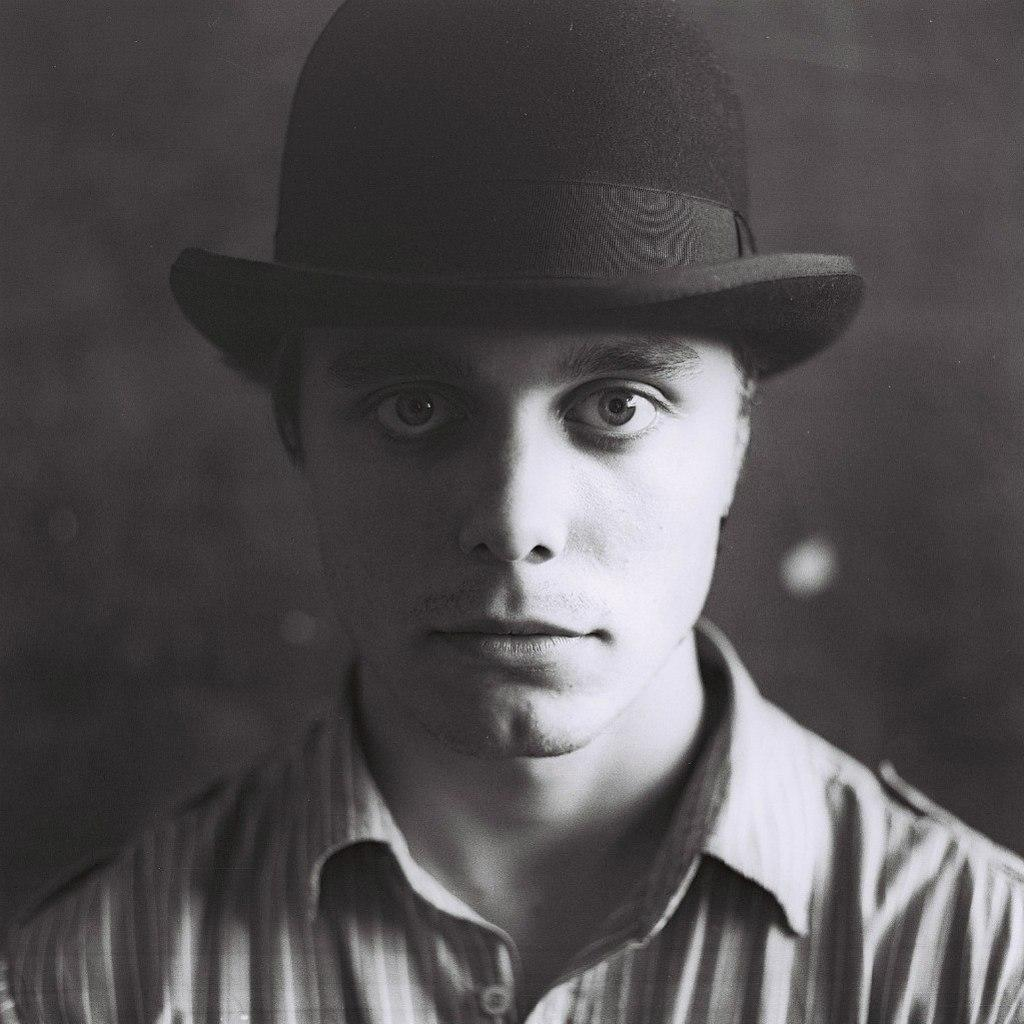What is the color scheme of the image? The image is black and white. What can be seen in the image? There is a person's face visible in the image. What type of apparel is the person wearing in the image? There is no information about the person's apparel in the image, as it is a black and white image of a person's face. 